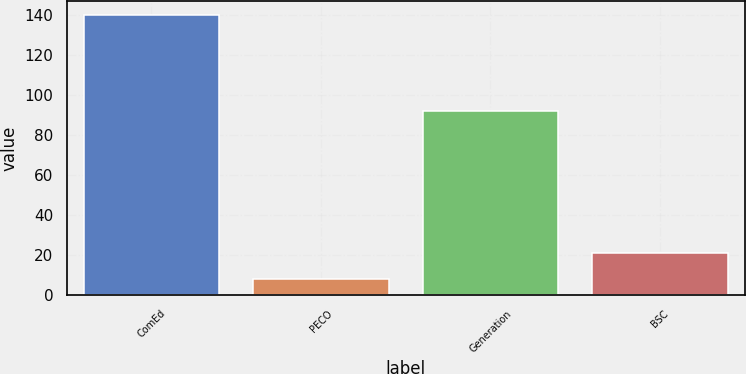<chart> <loc_0><loc_0><loc_500><loc_500><bar_chart><fcel>ComEd<fcel>PECO<fcel>Generation<fcel>BSC<nl><fcel>140<fcel>8<fcel>92<fcel>21.2<nl></chart> 